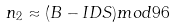<formula> <loc_0><loc_0><loc_500><loc_500>n _ { 2 } \approx ( B - I D S ) m o d 9 6</formula> 